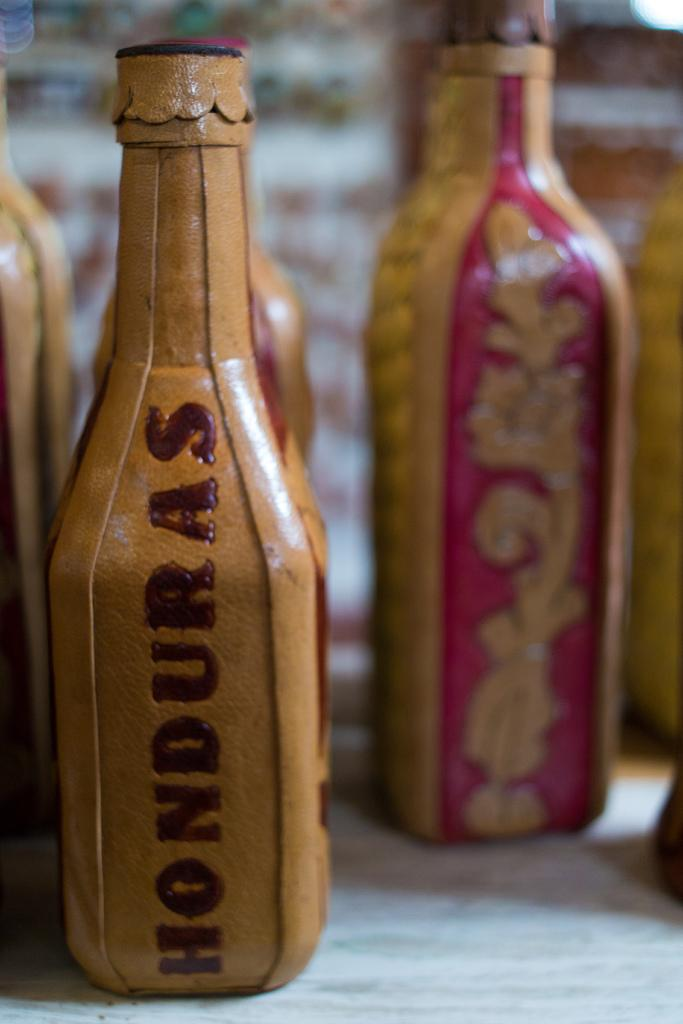<image>
Write a terse but informative summary of the picture. Leather covered bottles of which one says Honduras. 